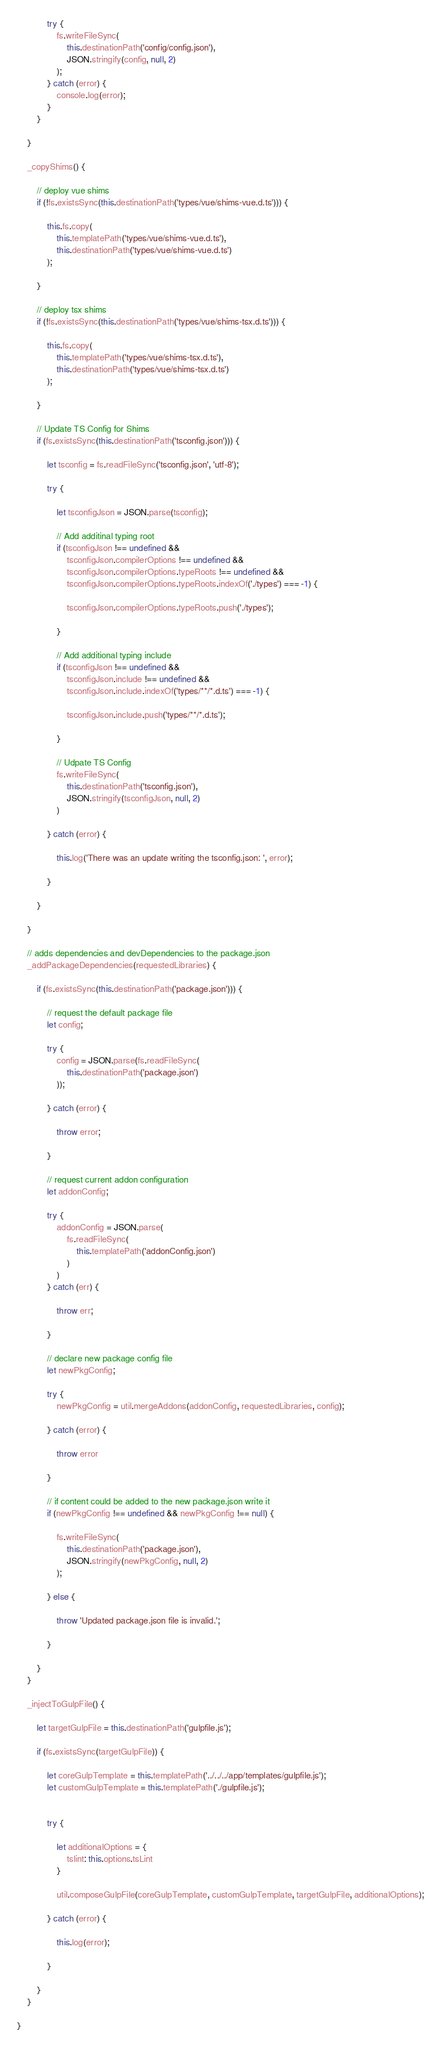Convert code to text. <code><loc_0><loc_0><loc_500><loc_500><_JavaScript_>            try {
                fs.writeFileSync(
                    this.destinationPath('config/config.json'),
                    JSON.stringify(config, null, 2)
                );
            } catch (error) {
                console.log(error);
            }
        }

    }

    _copyShims() {

        // deploy vue shims
        if (!fs.existsSync(this.destinationPath('types/vue/shims-vue.d.ts'))) {

            this.fs.copy(
                this.templatePath('types/vue/shims-vue.d.ts'),
                this.destinationPath('types/vue/shims-vue.d.ts')
            );

        }

        // deploy tsx shims
        if (!fs.existsSync(this.destinationPath('types/vue/shims-tsx.d.ts'))) {

            this.fs.copy(
                this.templatePath('types/vue/shims-tsx.d.ts'),
                this.destinationPath('types/vue/shims-tsx.d.ts')
            );

        }

        // Update TS Config for Shims
        if (fs.existsSync(this.destinationPath('tsconfig.json'))) {

            let tsconfig = fs.readFileSync('tsconfig.json', 'utf-8');

            try {

                let tsconfigJson = JSON.parse(tsconfig);

                // Add additinal typing root
                if (tsconfigJson !== undefined &&
                    tsconfigJson.compilerOptions !== undefined &&
                    tsconfigJson.compilerOptions.typeRoots !== undefined &&
                    tsconfigJson.compilerOptions.typeRoots.indexOf('./types') === -1) {

                    tsconfigJson.compilerOptions.typeRoots.push('./types');

                }

                // Add additional typing include
                if (tsconfigJson !== undefined &&
                    tsconfigJson.include !== undefined &&
                    tsconfigJson.include.indexOf('types/**/*.d.ts') === -1) {

                    tsconfigJson.include.push('types/**/*.d.ts');

                }

                // Udpate TS Config
                fs.writeFileSync(
                    this.destinationPath('tsconfig.json'),
                    JSON.stringify(tsconfigJson, null, 2)
                )

            } catch (error) {

                this.log('There was an update writing the tsconfig.json: ', error);

            }

        }

    }

    // adds dependencies and devDependencies to the package.json
    _addPackageDependencies(requestedLibraries) {

        if (fs.existsSync(this.destinationPath('package.json'))) {

            // request the default package file
            let config;

            try {
                config = JSON.parse(fs.readFileSync(
                    this.destinationPath('package.json')
                ));

            } catch (error) {

                throw error;

            }

            // request current addon configuration
            let addonConfig;

            try {
                addonConfig = JSON.parse(
                    fs.readFileSync(
                        this.templatePath('addonConfig.json')
                    )
                )
            } catch (err) {

                throw err;

            }

            // declare new package config file
            let newPkgConfig;

            try {
                newPkgConfig = util.mergeAddons(addonConfig, requestedLibraries, config);

            } catch (error) {

                throw error

            }

            // if content could be added to the new package.json write it
            if (newPkgConfig !== undefined && newPkgConfig !== null) {

                fs.writeFileSync(
                    this.destinationPath('package.json'),
                    JSON.stringify(newPkgConfig, null, 2)
                );

            } else {

                throw 'Updated package.json file is invalid.';

            }

        }
    }

    _injectToGulpFile() {

        let targetGulpFile = this.destinationPath('gulpfile.js');

        if (fs.existsSync(targetGulpFile)) {

            let coreGulpTemplate = this.templatePath('../../../app/templates/gulpfile.js');
            let customGulpTemplate = this.templatePath('./gulpfile.js');


            try {

                let additionalOptions = {
                    tslint: this.options.tsLint
                }

                util.composeGulpFile(coreGulpTemplate, customGulpTemplate, targetGulpFile, additionalOptions);

            } catch (error) {

                this.log(error);

            }

        }
    }

}
</code> 